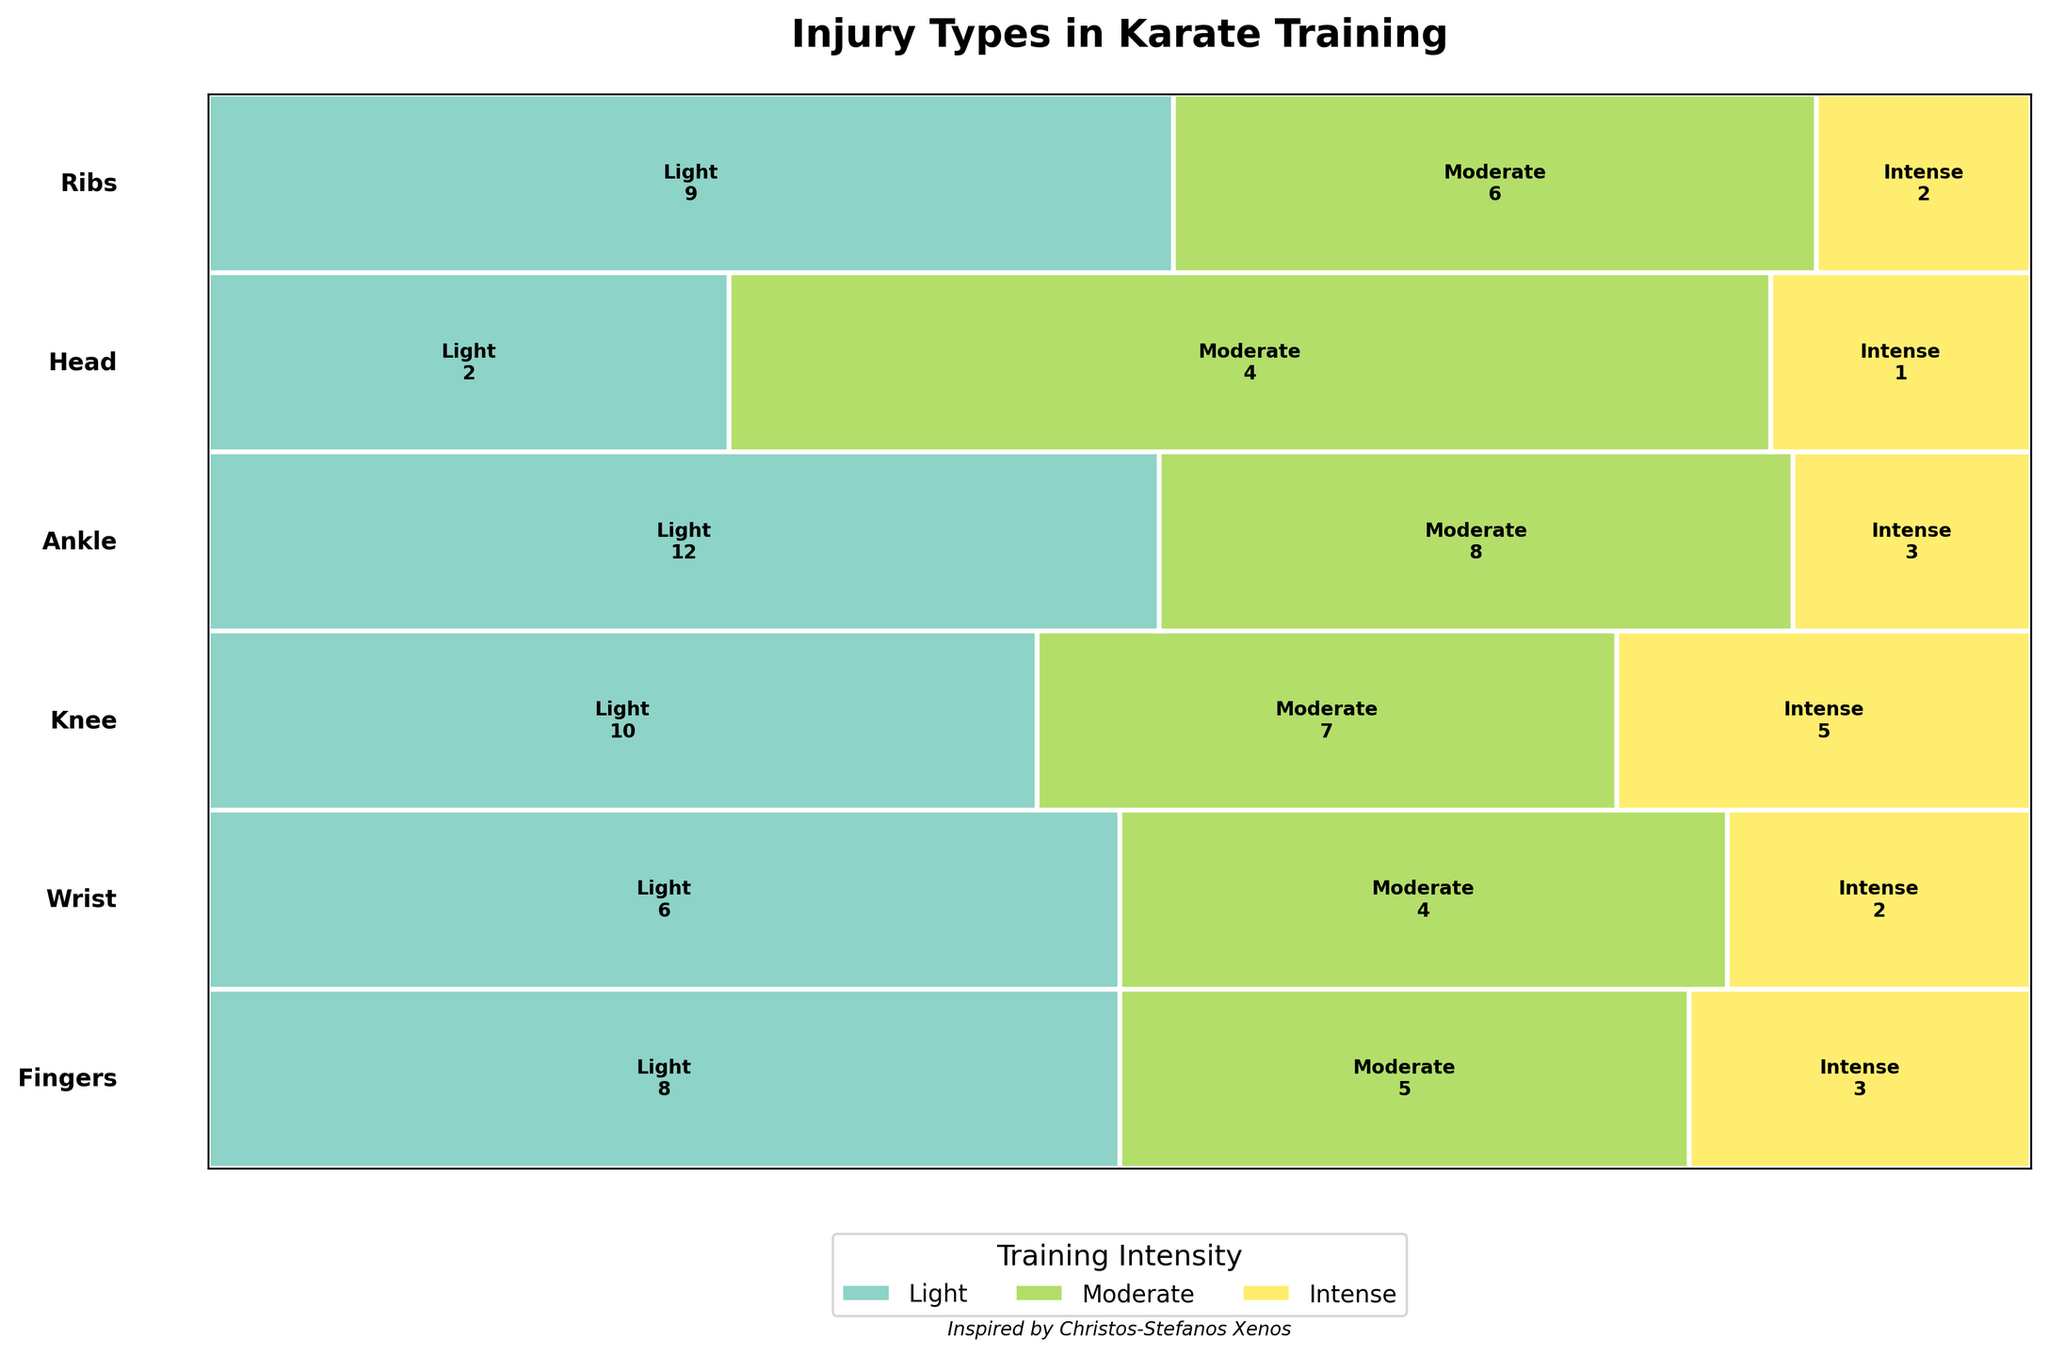What is the title of the figure? The title of the figure is usually found at the top and gives a summary of what the figure represents. Here, it states "Injury Types in Karate Training."
Answer: Injury Types in Karate Training What colors represent the different training intensities? The training intensities are represented by distinct colors in the mosaic plot. The color legend at the bottom indicates what each color stands for.
Answer: Different colors from a set palette Which body part has the highest number of injuries during light training? First, identify the color for "Light" training from the legend. Then, look for the body part's segment that has the largest width under "Light" training. The widest "Light" segment corresponds to the body part with the highest number.
Answer: Ankle How many injuries are observed for the Head during intense training? Locate the "Head" row and find the segment that corresponds to "Intense" training. The number inside this segment represents the count of injuries.
Answer: 1 Which injury type has the highest count in moderate training for the Wrist? Focus on the "Wrist" row and locate the "Moderate" training segment. Identify the number associated with each injury type within this segment. The one with the highest number gives the highest injury count.
Answer: Tendinitis Compare the count of Knee injuries during light and intense training. Which is higher? Locate the "Knee" row and find the segments for "Light" and "Intense" training. Compare the numbers inside these segments to determine which is higher.
Answer: Light Summarize the total injuries recorded for the Ankle across all training intensities. Look at the "Ankle" row and sum the numbers in all three segments for "Light," "Moderate," and "Intense" training to get the total. The counts are 12, 8, and 3, respectively.
Answer: 23 Which body parts have fractures as a notable injury type and what are the respective counts? Identify the segments labeled "Fracture" and note which body parts they are under. The counts for these segments give the respective injury numbers for fractures.
Answer: Fingers: 5, Wrist: 2, Ankle: 3, Ribs: 2 What is the most common injury during light training? Identify the "Light" training segments within each body part and compare the numbers to find the injury type that appears most frequently.
Answer: Ankle Sprain Which body part has the least variety of injury types across all intensities? For each body part, count the distinct injury types listed across the training intensities. The body part with the smallest number of different injury types has the least variety.
Answer: Head 